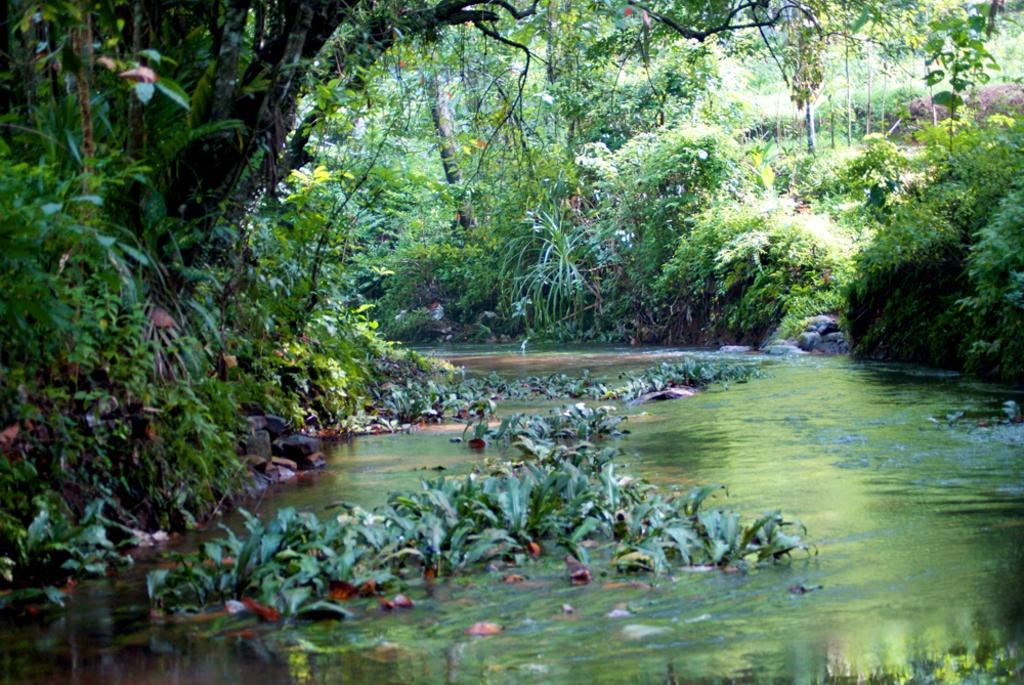What type of vegetation can be seen in the image? There are trees in the image. What is located at the bottom of the image? There are plants in the water at the bottom of the image. How many times did the person rub their elbow in the image? There is no person or elbow present in the image, as it only features trees and plants in the water. 